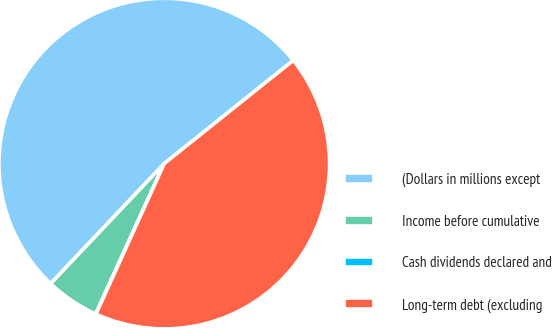Convert chart to OTSL. <chart><loc_0><loc_0><loc_500><loc_500><pie_chart><fcel>(Dollars in millions except<fcel>Income before cumulative<fcel>Cash dividends declared and<fcel>Long-term debt (excluding<nl><fcel>52.2%<fcel>5.25%<fcel>0.03%<fcel>42.52%<nl></chart> 